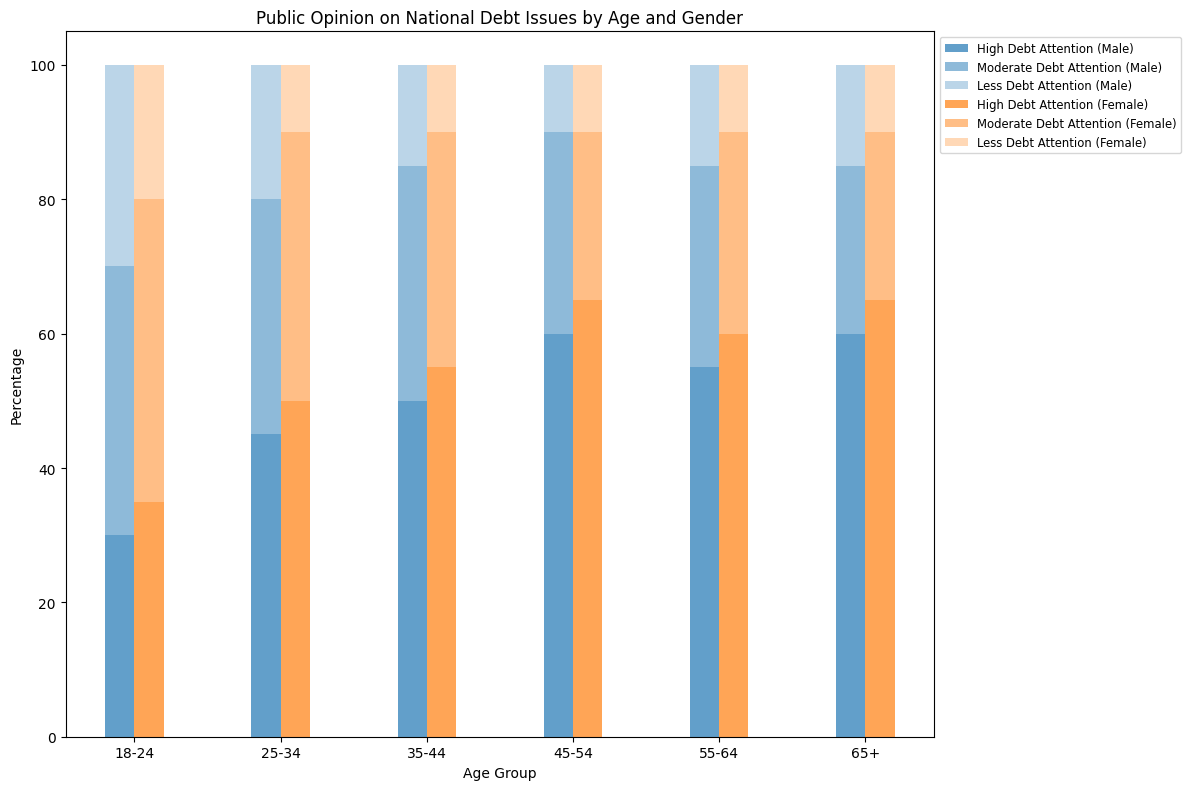Which age and gender group shows the highest percentage of support for high debt attention? To find this, look for the tallest single segment representing high debt attention across all groups. The tallest segment is for females aged 45-54.
Answer: Females aged 45-54 Which age group shows the highest combined support (high, moderate, and less) for debt attention among males? Sum up the three segments' heights for each age group within males. The total sum is highest for males aged 45-54.
Answer: Males aged 45-54 What is the total percentage of support for high and moderate debt attention among females aged 18-24? Add the heights of the segments representing high (35%) and moderate (45%) debt attention for females aged 18-24.
Answer: 80% Which age group shows the least support for less debt attention among females? Look for the smallest segment representing less debt attention among all female age groups. The smallest segment is for females aged 25-34, 35-44, 45-54, and 65+.
Answer: Females aged 25-34, 35-44, 45-54, 65+ How does the support for moderate debt attention among males aged 55-64 compare to females aged 55-64? Compare the heights of the middle segments for both age groups. Males aged 55-64 have 30%, and females aged 55-64 also have 30%.
Answer: Equal What is the average support for high debt attention among females aged 25-34 and 35-44? Average the heights of the first segments representing high debt attention for the two age groups: (50% + 55%) / 2.
Answer: 52.5% In which age group do females show a higher total percentage of support for debt attention than males? Calculate the sum of all segments for each gender within an age group and compare. In all age groups, females show higher total support compared to males of the same age.
Answer: All age groups What is the difference in support for less debt attention between males aged 65+ and females aged 65+? Subtract the support for less debt attention for females aged 65+ (10%) from that of males aged 65+ (15%).
Answer: 5% Which gender has the highest support for high debt attention across all ages? Examine the highest segments for both genders across all age groups. Females in the 45-54 and 65+ age groups show the highest support at 65%.
Answer: Female What can be inferred about the trend of support for high debt attention as age increases for both genders? Observe the height trend of the first segments (high debt attention) as age increases. Both genders generally show an increasing trend in support for high debt attention with age.
Answer: Increasing trend 